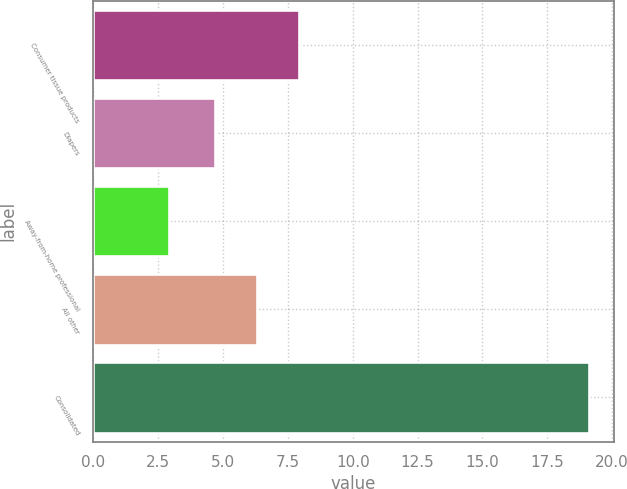<chart> <loc_0><loc_0><loc_500><loc_500><bar_chart><fcel>Consumer tissue products<fcel>Diapers<fcel>Away-from-home professional<fcel>All other<fcel>Consolidated<nl><fcel>7.94<fcel>4.7<fcel>2.9<fcel>6.32<fcel>19.1<nl></chart> 